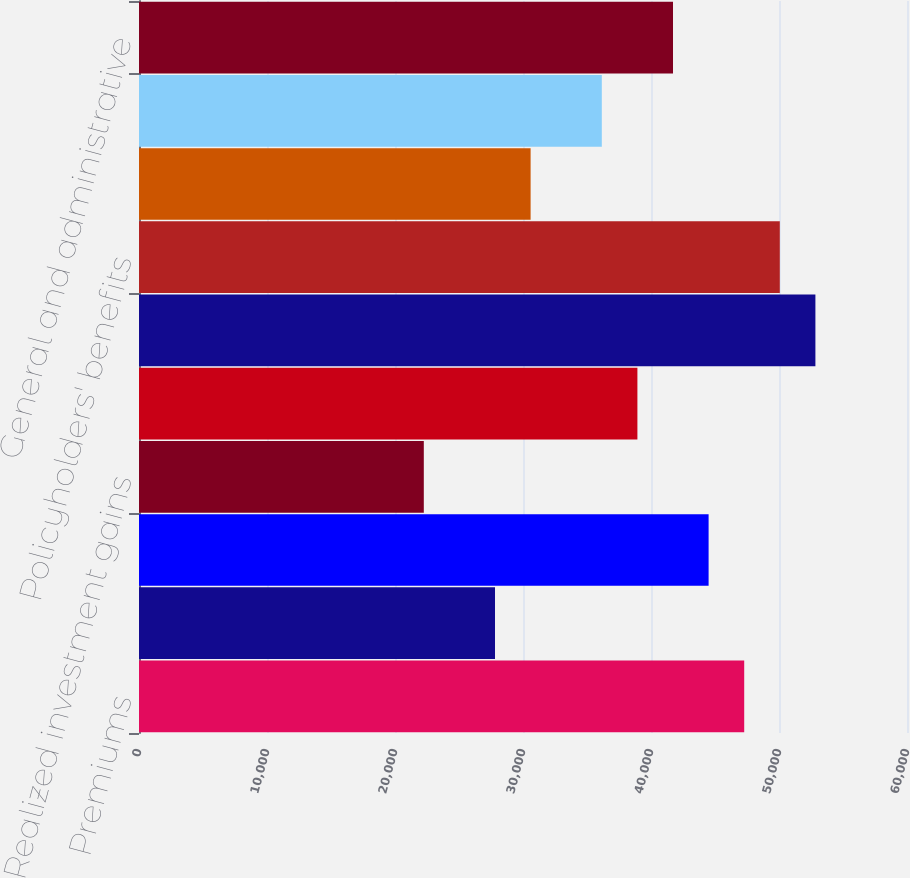Convert chart. <chart><loc_0><loc_0><loc_500><loc_500><bar_chart><fcel>Premiums<fcel>Policy charges and fee income<fcel>Net investment income<fcel>Realized investment gains<fcel>Asset management fees and<fcel>Total revenues<fcel>Policyholders' benefits<fcel>Interest credited to<fcel>Dividends to policyholders<fcel>General and administrative<nl><fcel>47281.7<fcel>27813<fcel>44500.5<fcel>22250.5<fcel>38938<fcel>52844.2<fcel>50062.9<fcel>30594.3<fcel>36156.7<fcel>41719.2<nl></chart> 